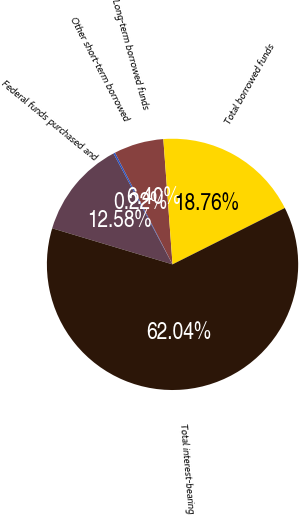<chart> <loc_0><loc_0><loc_500><loc_500><pie_chart><fcel>Federal funds purchased and<fcel>Other short-term borrowed<fcel>Long-term borrowed funds<fcel>Total borrowed funds<fcel>Total interest-bearing<nl><fcel>12.58%<fcel>0.22%<fcel>6.4%<fcel>18.76%<fcel>62.04%<nl></chart> 